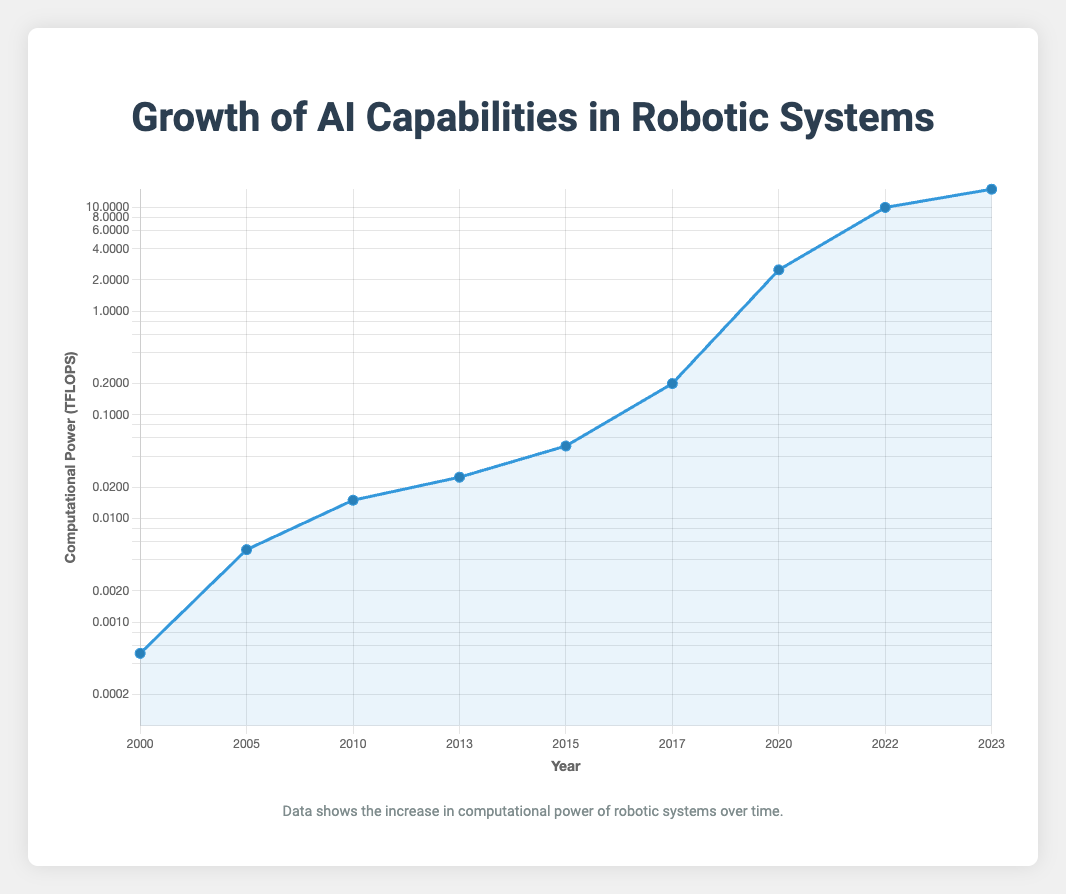Which robotic system had the highest computational power in 2023? By looking at the data points for the year 2023, we can see which system had the highest computational power. Agility Robotics in 2023 has the highest with 15 TFLOPS.
Answer: Agility Robotics How many times did the computational power of Pepper increase from 2000 to 2015? First, find the computational power in 2000 (ASIMO: 0.5 GFLOPS). Then find the computational power in 2015 (Pepper: 50 GFLOPS). Convert both to TFLOPS (0.0005 TFLOPS and 0.05 TFLOPS). The increase is 0.05 / 0.0005 = 100 times.
Answer: 100 times Which year saw the most significant jump in computational power compared to the previous data point? By looking at the differences between consecutive years and focusing on the largest jump, we see 2020-2022, from 2.5 TFLOPS to 10 TFLOPS. Calculating, (10 - 2.5) / 2.5 = 3 times larger than the previous (or 7.5 TFLOPS increase).
Answer: 2020 to 2022 What was the computational power of Sophia in GFLOPS? Sophia's computational power in 2017 was given as 0.2 TFLOPS. Convert TFLOPS to GFLOPS by multiplying by 1000: 0.2 * 1000 = 200 GFLOPS.
Answer: 200 GFLOPS What is the average computational power of robotic systems from 2000 to 2010 in GFLOPS? Sum computational power from 2000 (0.5 GFLOPS), 2005 (5 GFLOPS) and 2010 (15 GFLOPS): 0.5 + 5 + 15 = 20. Divide by the number of systems: 20 / 3 = 6.67 GFLOPS.
Answer: 6.67 GFLOPS Does the computational power growth appear exponential or linear over the years? From observing the logarithmic scale on the y-axis, we note that the computational power increases significantly over time, suggesting an exponential growth pattern rather than linear.
Answer: Exponential Which robotic system debuted with the smallest computational power? Looking at the first data point in the plot, ASIMO in 2000 had the smallest computational power of 0.5 GFLOPS (or 0.0005 TFLOPS).
Answer: ASIMO How many years did it take for the computational power to increase from 0.5 GFLOPS to 50 GFLOPS? ASIMO had 0.5 GFLOPS in 2000, and Pepper had 50 GFLOPS in 2015, so it took 2015 - 2000 = 15 years.
Answer: 15 years What is the total computational power of all robotic systems in 2023 in TFLOPS? For 2023, only Agility Robotics is listed with 15 TFLOPS. Thus, the total computational power is 15 TFLOPS.
Answer: 15 TFLOPS Comparing the computational power of Digit in 2020 with Sophia in 2017, how many times more powerful is Digit? Digit's computational power in 2020 is 2.5 TFLOPS, and Sophia's in 2017 is 0.2 TFLOPS. To find how many times more powerful, 2.5 / 0.2 = 12.5 times more powerful.
Answer: 12.5 times 